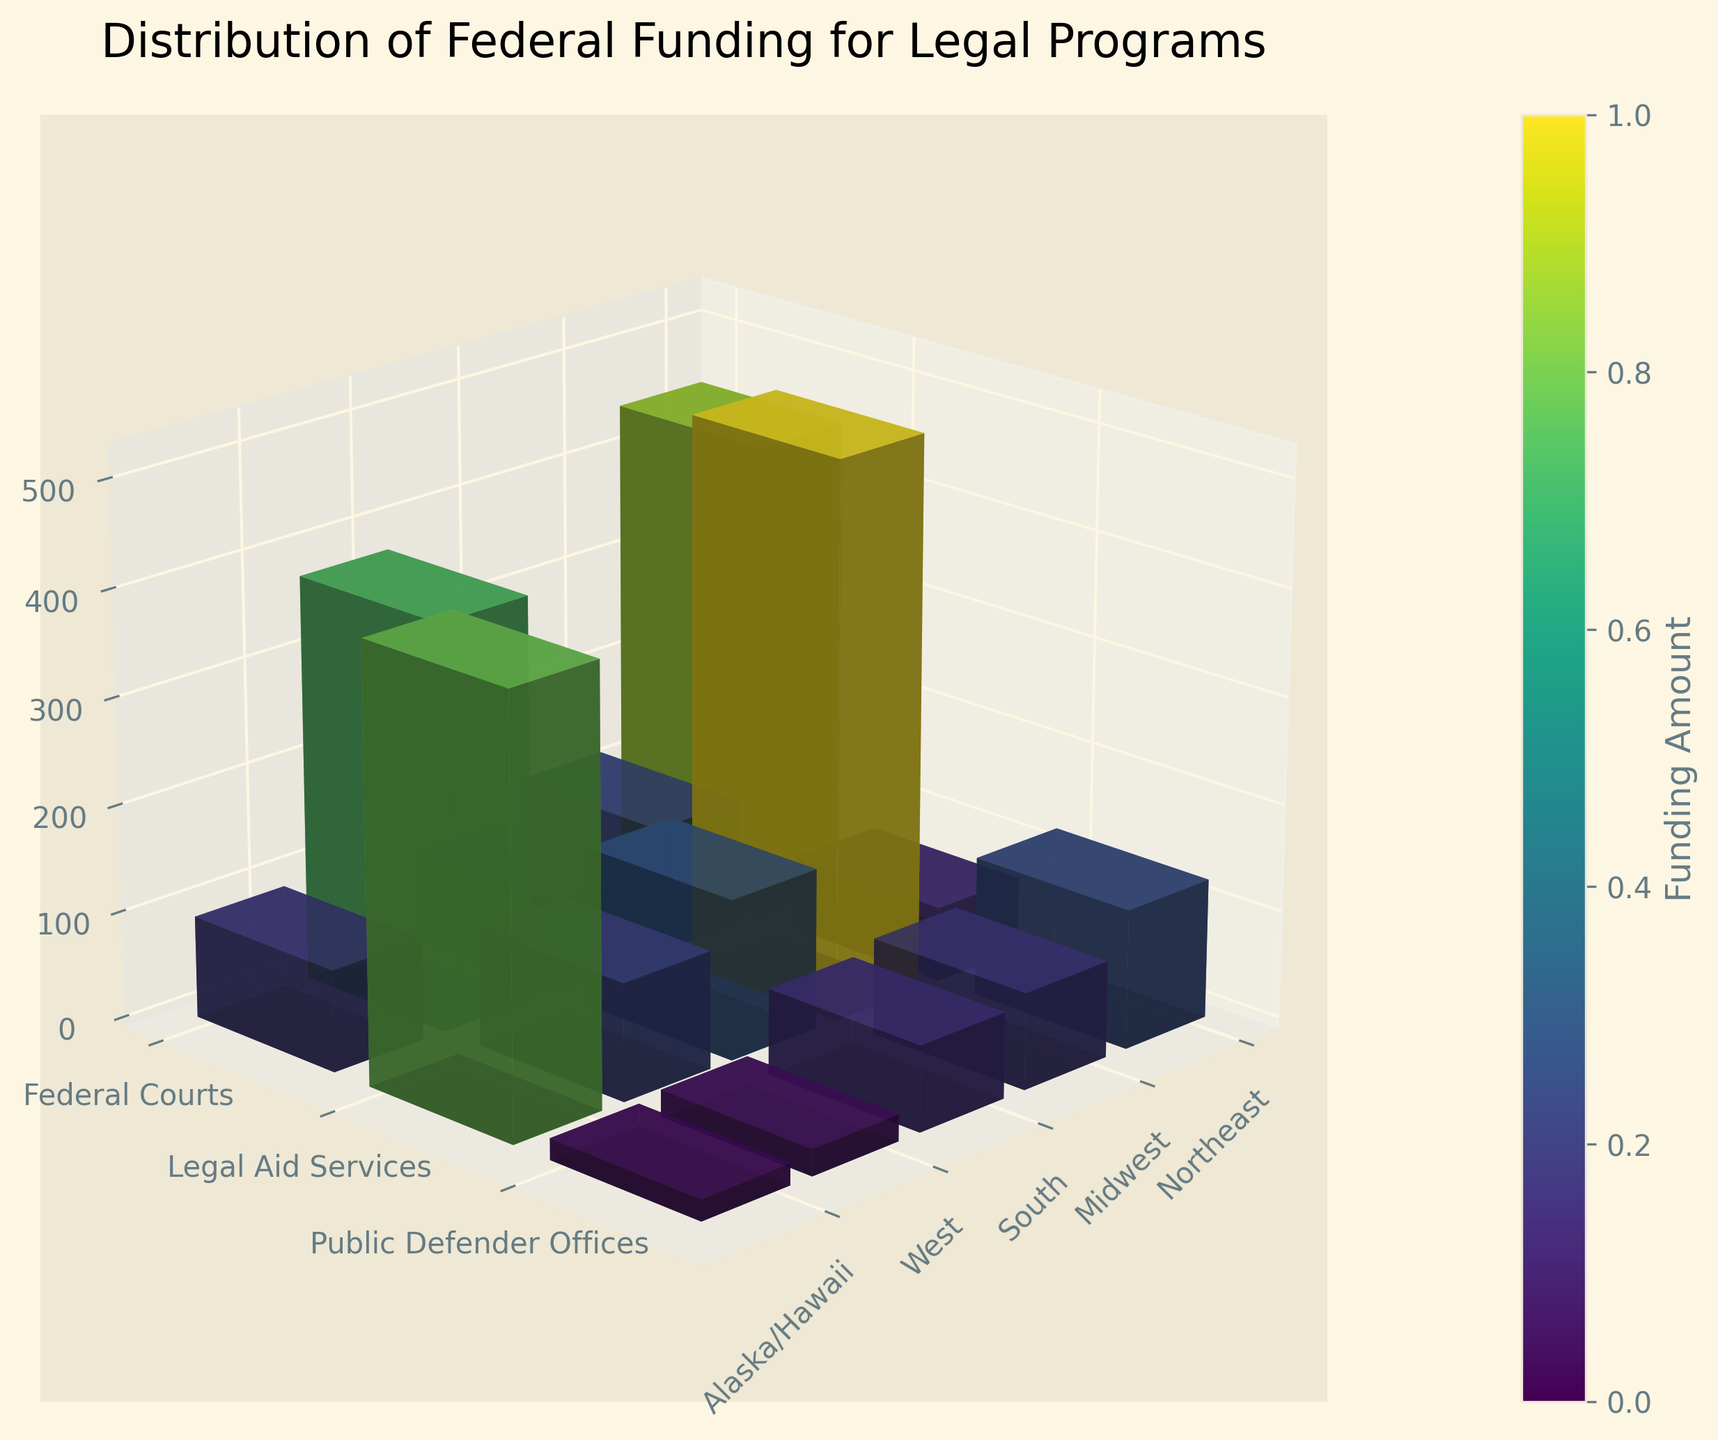What's the title of the figure? The title is usually displayed at the top of the figure. Here, it reads "Distribution of Federal Funding for Legal Programs".
Answer: Distribution of Federal Funding for Legal Programs Which region receives the highest funding for Federal Courts? By comparing the height of the bars representing Federal Courts across all regions, the tallest bar corresponds to the South region.
Answer: South How much funding does the West region receive for Public Defender Offices? On the y-axis, find the label for Public Defender Offices, then look at the bar for the West region. The height indicates 90 million.
Answer: 90 million Which region receives the least total funding across all programs? Sum the funding for each region across all programs. The sum for Alaska/Hawaii is 125 million, which is the lowest compared to other regions.
Answer: Alaska/Hawaii Compare the funding difference between Legal Aid Services in the Northeast and Midwest regions. The funding for Legal Aid Services in the Northeast is 120 million and in the Midwest is 95 million. The difference is 120 - 95 = 25 million.
Answer: 25 million How does the funding for Public Defender Offices in the South compare to that in the Midwest? The bar heights for Public Defender Offices in the South and Midwest are 110 million and 70 million, respectively. The South receives more funding.
Answer: South Which program receives the highest funding in the West region? By looking at the bars for the West region, the Federal Courts bar has the highest height, indicating the highest funding.
Answer: Federal Courts What's the average funding for Legal Aid Services across all regions? Sum the funding for Legal Aid Services (120 + 95 + 150 + 130 + 25 = 520 million) and divide by the number of regions (5). The average is 520/5 = 104 million.
Answer: 104 million Identify the program with the smallest funding across all regions. The shortest bar among all programs and regions is for Public Defender Offices in Alaska/Hawaii, which is 20 million.
Answer: Public Defender Offices in Alaska/Hawaii 